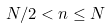<formula> <loc_0><loc_0><loc_500><loc_500>N / 2 < n \leq N</formula> 